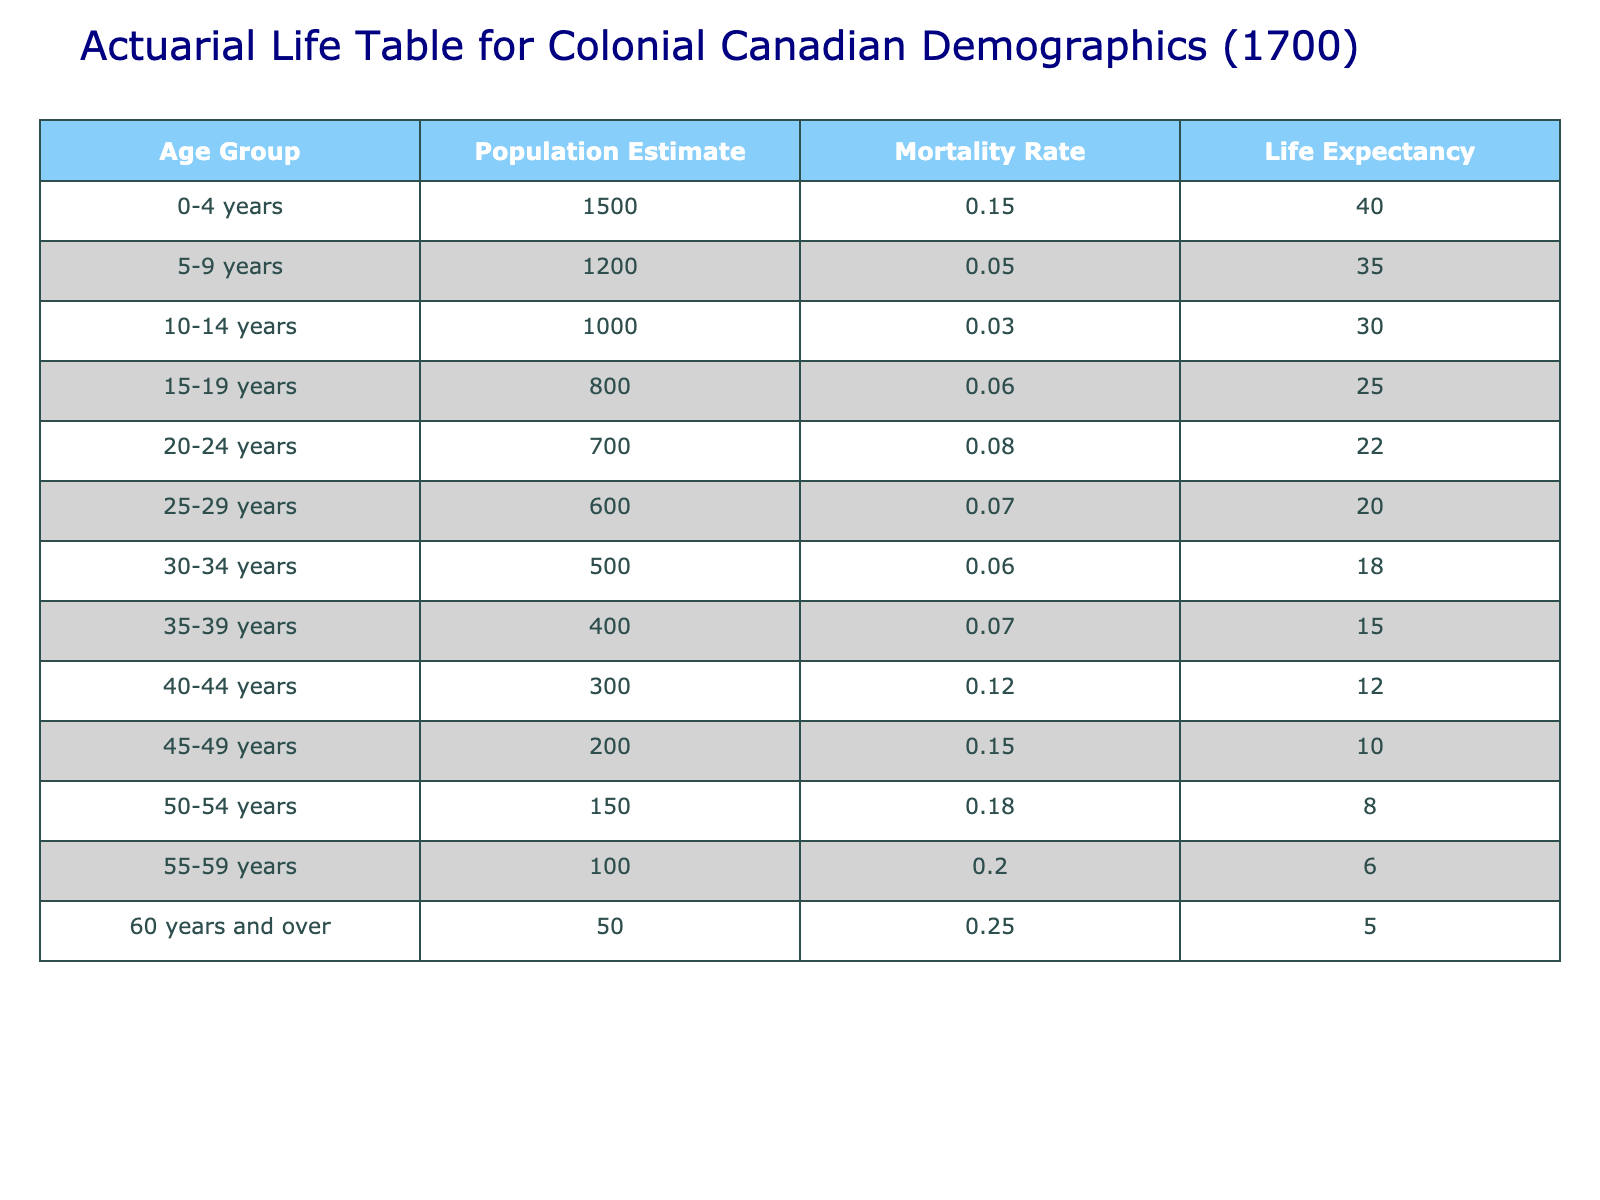What is the population estimate for the age group 0-4 years? The table lists the population estimate for the age group 0-4 years explicitly under the "Population Estimate" column, which shows the value of 1500.
Answer: 1500 Which age group has the highest mortality rate? To determine the age group with the highest mortality rate, we can compare the values in the "Mortality Rate" column across all age groups. The maximum value is 0.25, corresponding to the age group "60 years and over."
Answer: 60 years and over What is the average life expectancy for the age groups 20-24 years and 25-29 years combined? The life expectancy for the age group 20-24 years is 22, and for 25-29 years it's 20. To find the average, we sum these two values (22 + 20 = 42) and divide by 2, resulting in an average of 21.
Answer: 21 Is the mortality rate for the age group 50-54 years greater than the mortality rate for the age group 30-34 years? The mortality rate for the age group 50-54 years is 0.18, while the mortality rate for 30-34 years is 0.06. Since 0.18 is greater than 0.06, the statement is true.
Answer: Yes What is the total population estimate for all age groups combined? To find the total population estimate, we sum all population estimates from each age group: 1500 + 1200 + 1000 + 800 + 700 + 600 + 500 + 400 + 300 + 200 + 150 + 100 + 50 = 5500.
Answer: 5500 Which age group has a life expectancy of 10 years? Looking at the "Life Expectancy" column, we find that the age group corresponding to a life expectancy of 10 years is "45-49 years."
Answer: 45-49 years How many age groups have a mortality rate greater than 0.1? By examining the "Mortality Rate" column, we identify the age groups with rates above 0.1: 0.12 (40-44 years), 0.15 (45-49 years), 0.18 (50-54 years), 0.20 (55-59 years), and 0.25 (60 years and over). There are five such groups in total.
Answer: 5 What is the difference in life expectancy between the age groups 30-34 years and 50-54 years? The life expectancy for 30-34 years is 18, and for 50-54 years, it is 8. To find the difference, subtract the latter from the former: 18 - 8 = 10.
Answer: 10 Which age group has the lowest population estimate? The lowest population estimate in the table is present for the age group "60 years and over" with a population of 50.
Answer: 60 years and over 